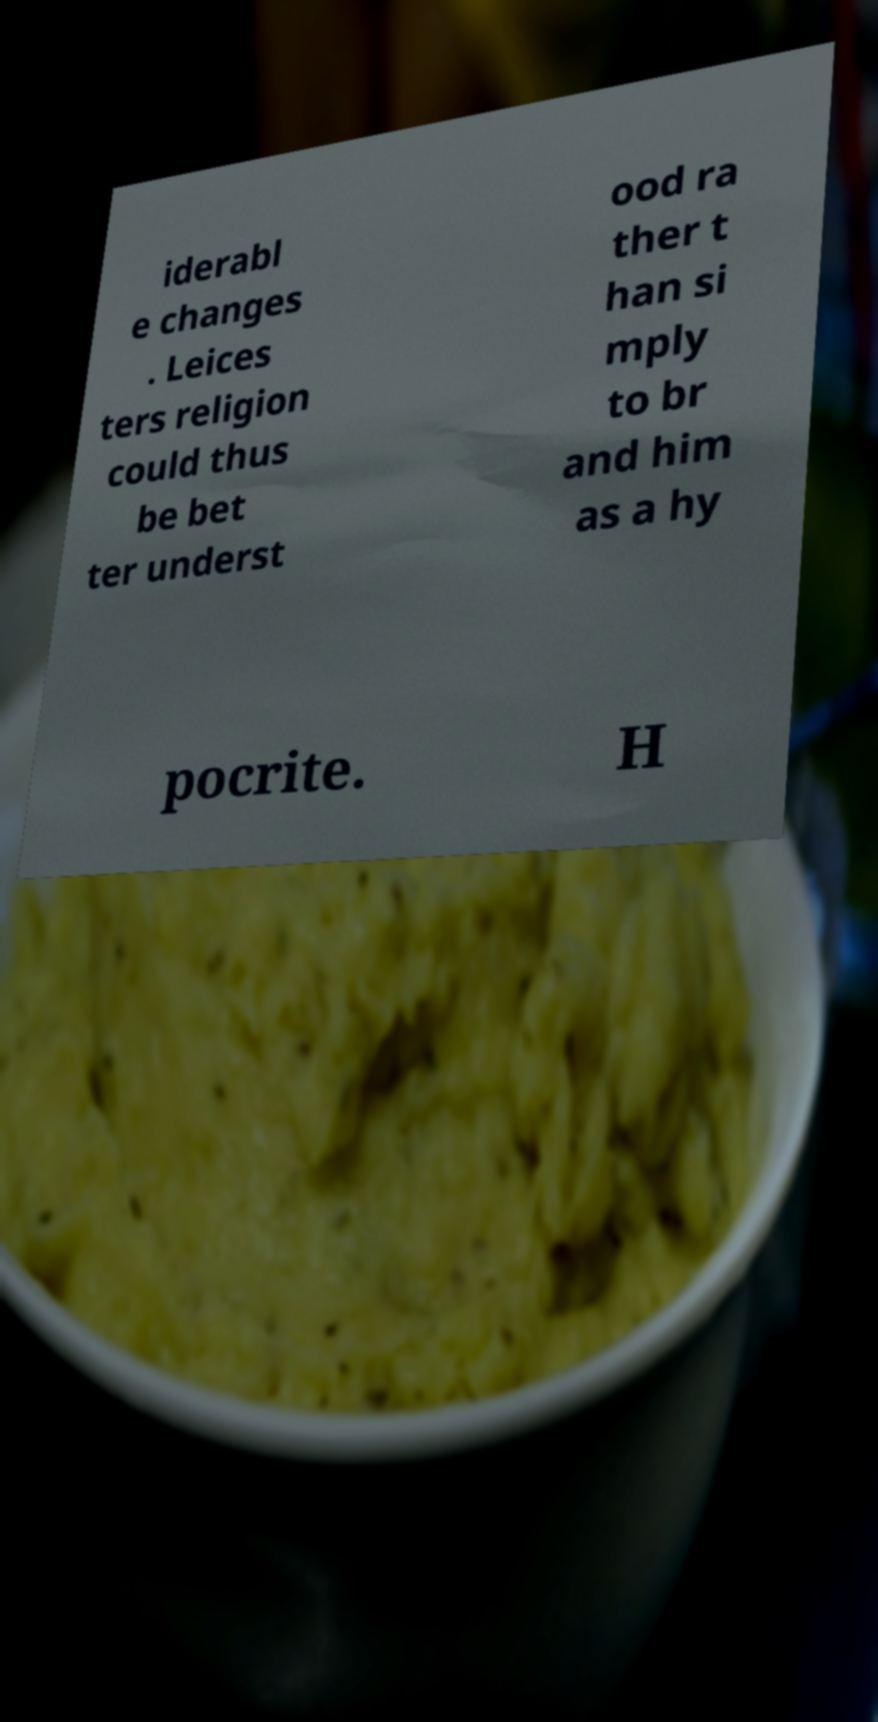Can you read and provide the text displayed in the image?This photo seems to have some interesting text. Can you extract and type it out for me? iderabl e changes . Leices ters religion could thus be bet ter underst ood ra ther t han si mply to br and him as a hy pocrite. H 